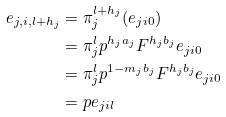Convert formula to latex. <formula><loc_0><loc_0><loc_500><loc_500>e _ { j , i , l + h _ { j } } & = \pi _ { j } ^ { l + h _ { j } } ( e _ { j i 0 } ) \\ & = \pi _ { j } ^ { l } p ^ { h _ { j } a _ { j } } F ^ { h _ { j } b _ { j } } e _ { j i 0 } \\ & = \pi _ { j } ^ { l } p ^ { 1 - m _ { j } b _ { j } } F ^ { h _ { j } b _ { j } } e _ { j i 0 } \\ & = p e _ { j i l }</formula> 